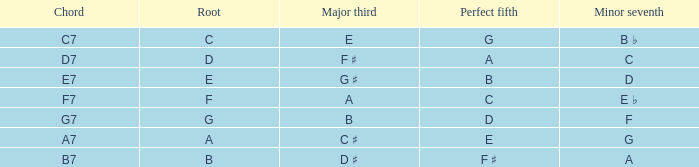What is the Perfect fifth with a Minor that is seventh of d? B. 